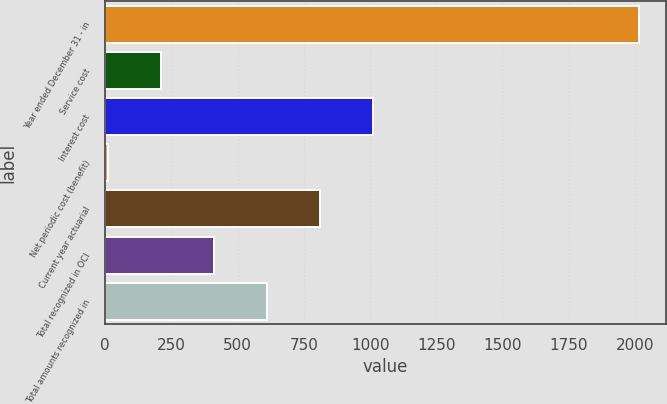Convert chart. <chart><loc_0><loc_0><loc_500><loc_500><bar_chart><fcel>Year ended December 31 - in<fcel>Service cost<fcel>Interest cost<fcel>Net periodic cost (benefit)<fcel>Current year actuarial<fcel>Total recognized in OCI<fcel>Total amounts recognized in<nl><fcel>2015<fcel>209.6<fcel>1012<fcel>9<fcel>811.4<fcel>410.2<fcel>610.8<nl></chart> 